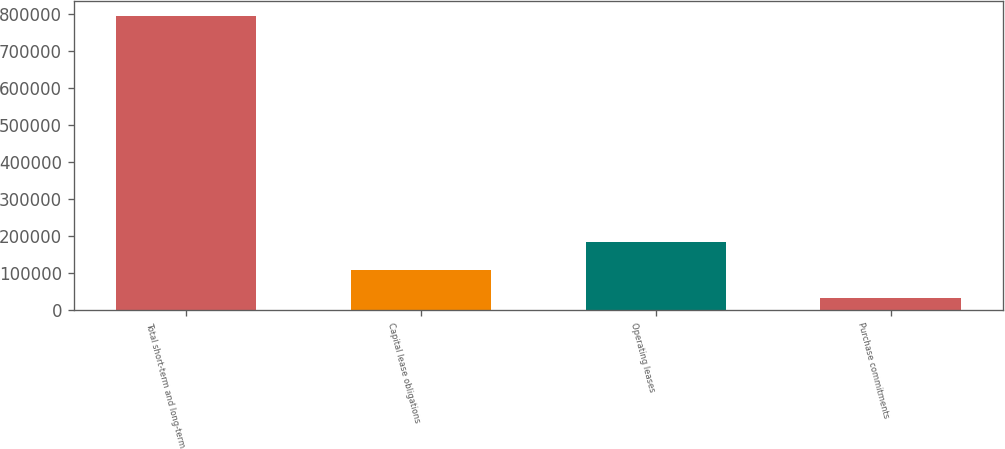Convert chart to OTSL. <chart><loc_0><loc_0><loc_500><loc_500><bar_chart><fcel>Total short-term and long-term<fcel>Capital lease obligations<fcel>Operating leases<fcel>Purchase commitments<nl><fcel>794000<fcel>107571<fcel>183841<fcel>31301<nl></chart> 